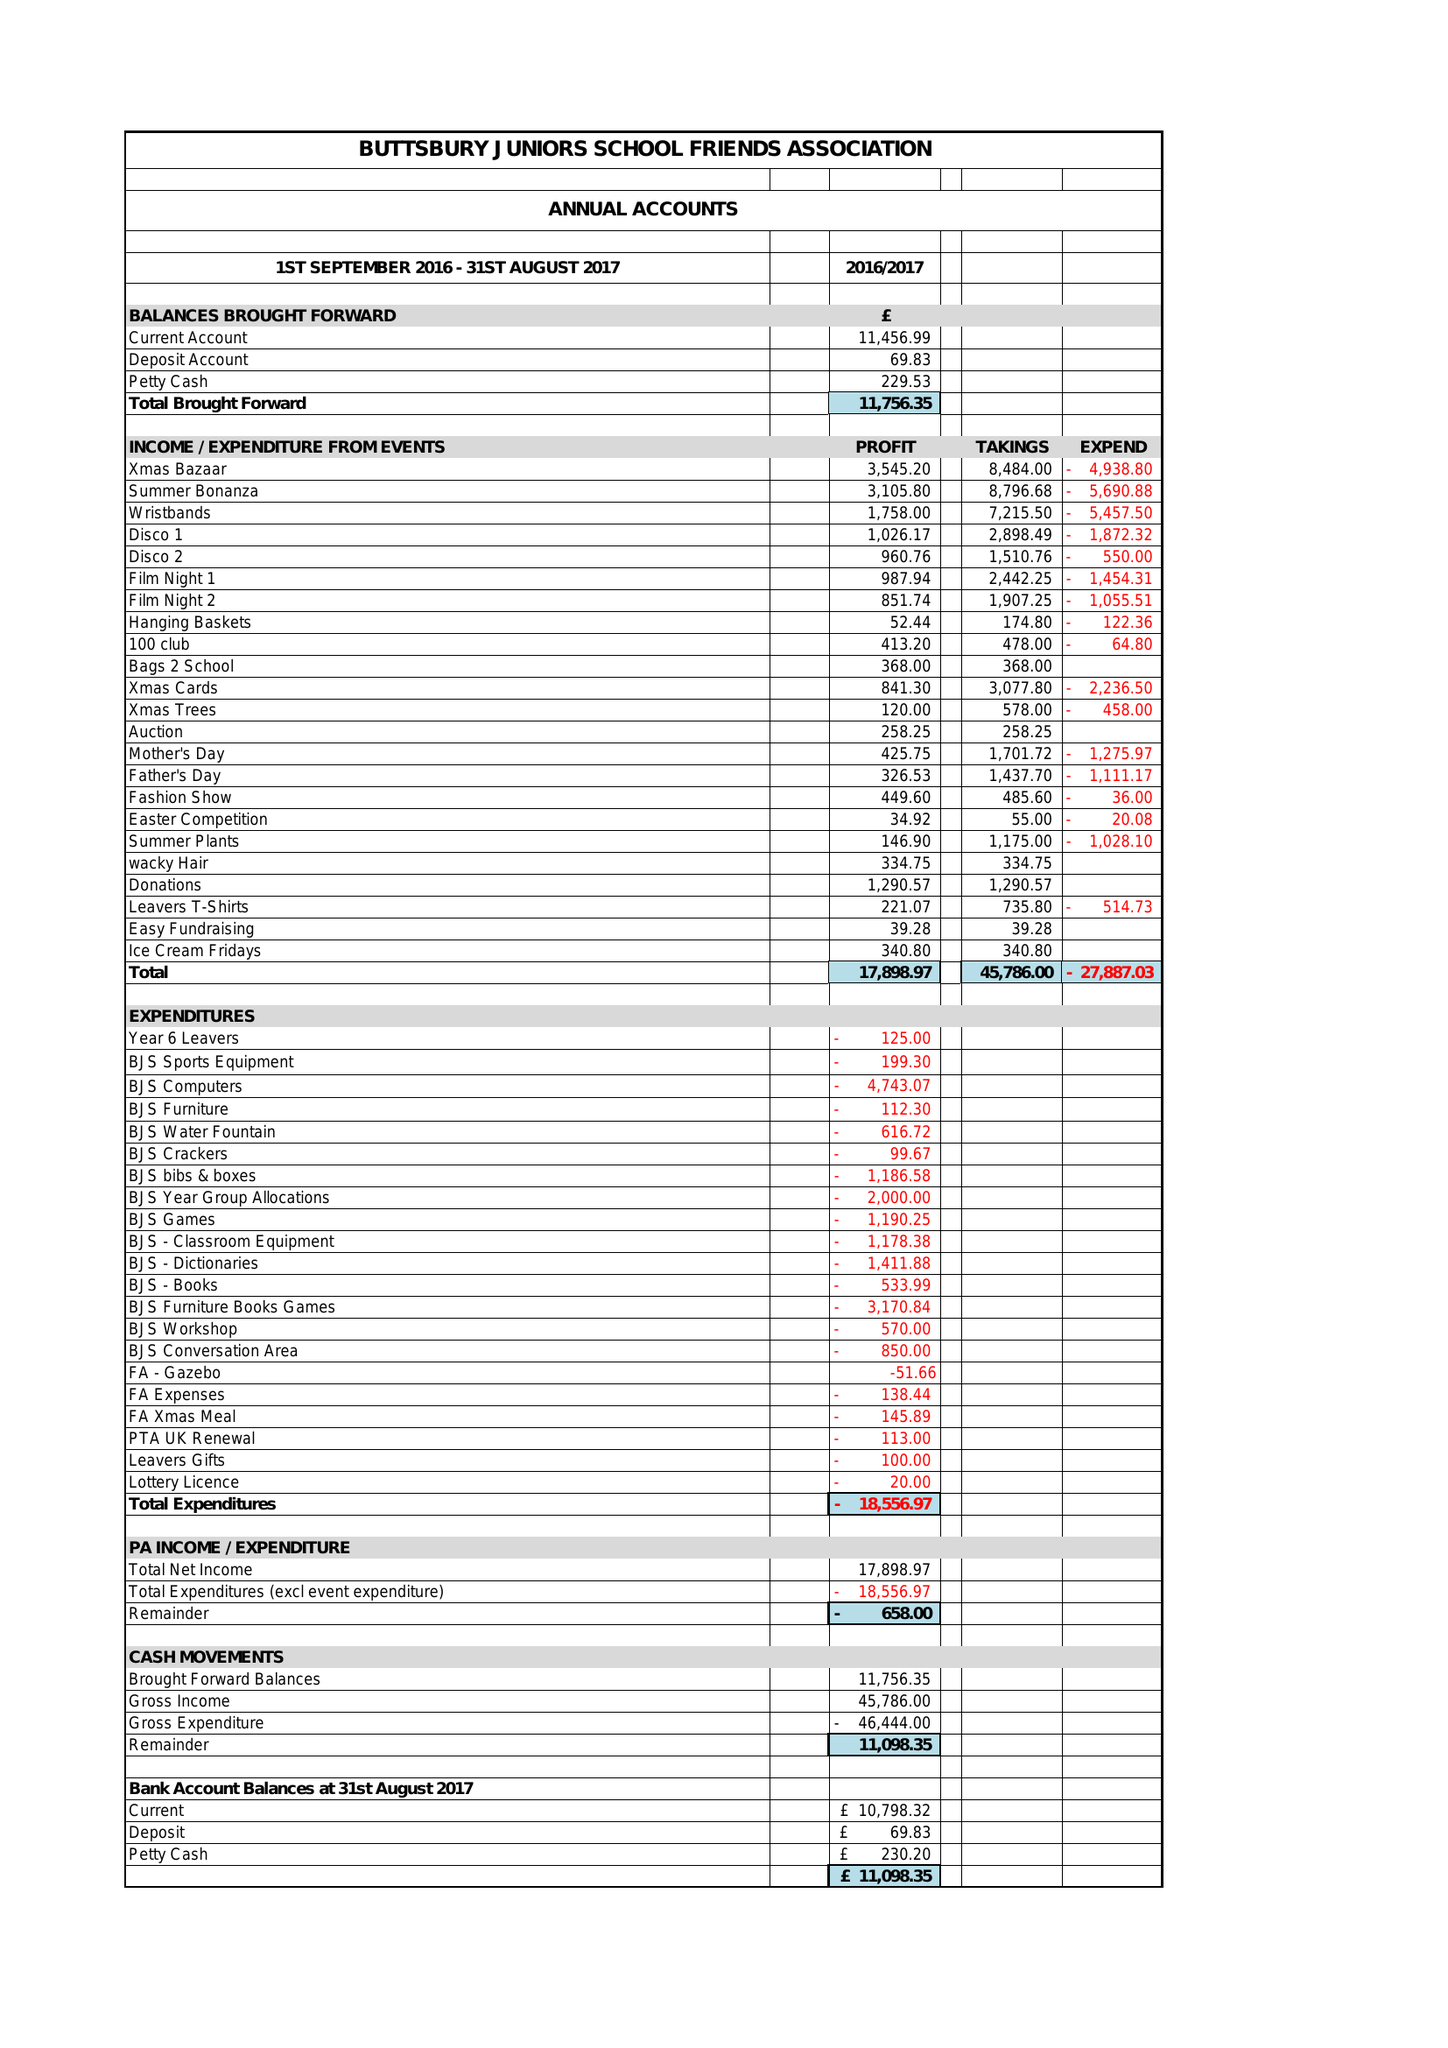What is the value for the charity_number?
Answer the question using a single word or phrase. 1128855 